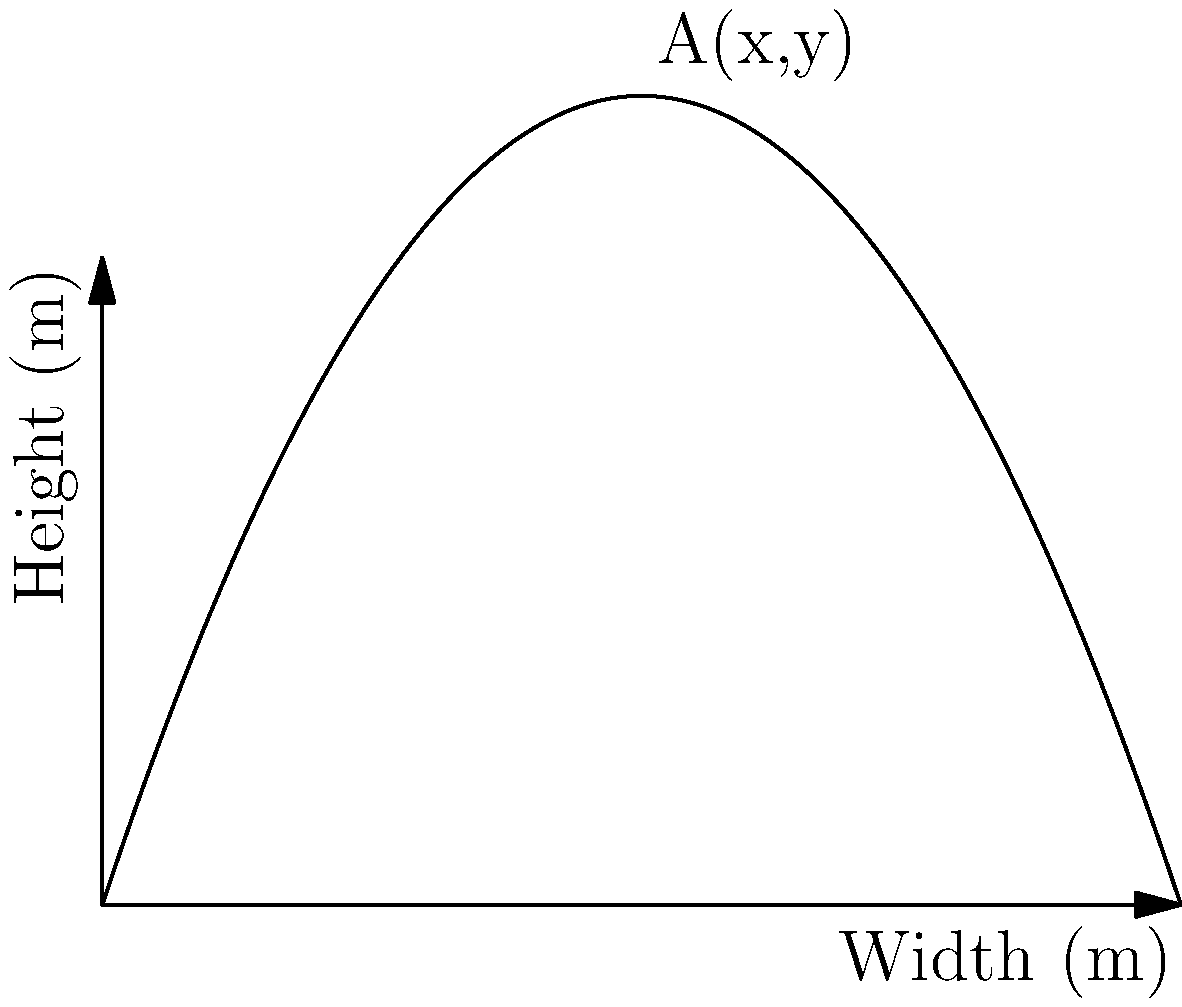A Zoppo-inspired composition requires a canvas with a rectangular shape. The height of the canvas is determined by the function $y = 3x(1-\frac{x}{5})$, where $x$ is the width in meters. What are the dimensions of the canvas that will maximize its area, and what is this maximum area? To solve this optimization problem, we'll follow these steps:

1) The area of the canvas is given by $A(x) = xy = 3x^2(1-\frac{x}{5})$.

2) Expand the area function:
   $A(x) = 3x^2 - \frac{3x^3}{5}$

3) To find the maximum, we need to find where $\frac{dA}{dx} = 0$:
   $\frac{dA}{dx} = 6x - \frac{9x^2}{5}$

4) Set this equal to zero and solve:
   $6x - \frac{9x^2}{5} = 0$
   $30x - 9x^2 = 0$
   $x(30 - 9x) = 0$
   $x = 0$ or $x = \frac{10}{3}$

5) The second solution, $x = \frac{10}{3}$, gives us the width that maximizes the area.

6) To find the height, we substitute this back into our original height function:
   $y = 3(\frac{10}{3})(1-\frac{10/3}{5}) = 10(1-\frac{2}{3}) = \frac{10}{3}$

7) The maximum area is:
   $A(\frac{10}{3}) = \frac{10}{3} \cdot \frac{10}{3} = \frac{100}{9}$

Therefore, the optimal dimensions are $\frac{10}{3}$ m by $\frac{10}{3}$ m, and the maximum area is $\frac{100}{9}$ square meters.
Answer: Width: $\frac{10}{3}$ m, Height: $\frac{10}{3}$ m, Area: $\frac{100}{9}$ m² 